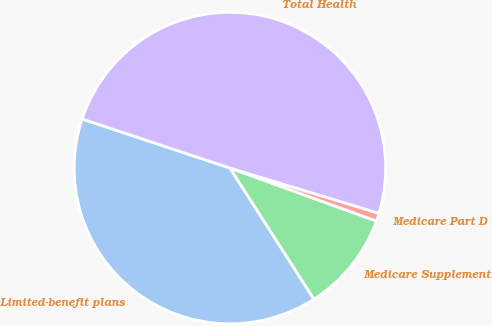Convert chart. <chart><loc_0><loc_0><loc_500><loc_500><pie_chart><fcel>Limited-benefit plans<fcel>Medicare Supplement<fcel>Medicare Part D<fcel>Total Health<nl><fcel>39.17%<fcel>10.41%<fcel>0.83%<fcel>49.59%<nl></chart> 